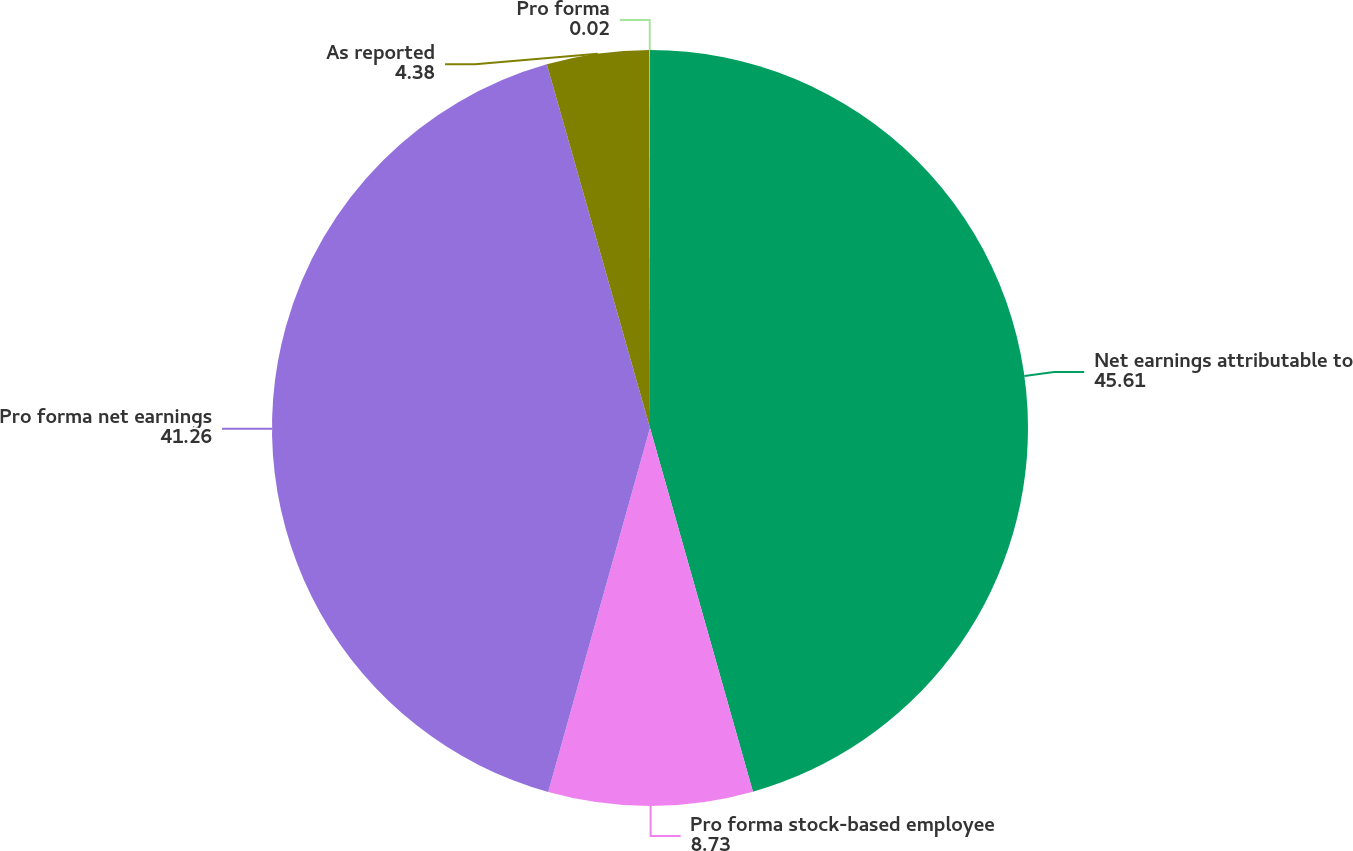Convert chart. <chart><loc_0><loc_0><loc_500><loc_500><pie_chart><fcel>Net earnings attributable to<fcel>Pro forma stock-based employee<fcel>Pro forma net earnings<fcel>As reported<fcel>Pro forma<nl><fcel>45.61%<fcel>8.73%<fcel>41.26%<fcel>4.38%<fcel>0.02%<nl></chart> 